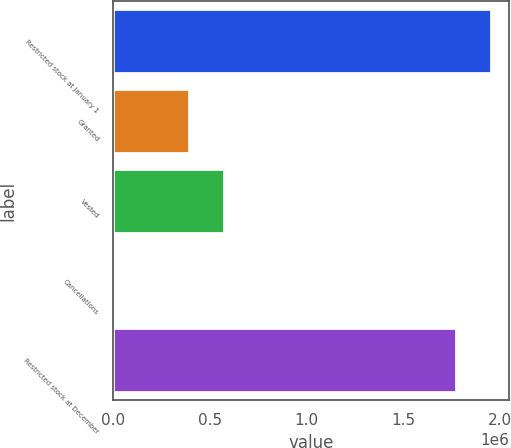Convert chart. <chart><loc_0><loc_0><loc_500><loc_500><bar_chart><fcel>Restricted stock at January 1<fcel>Granted<fcel>Vested<fcel>Cancellations<fcel>Restricted stock at December<nl><fcel>1.95224e+06<fcel>394928<fcel>575505<fcel>11975<fcel>1.77166e+06<nl></chart> 